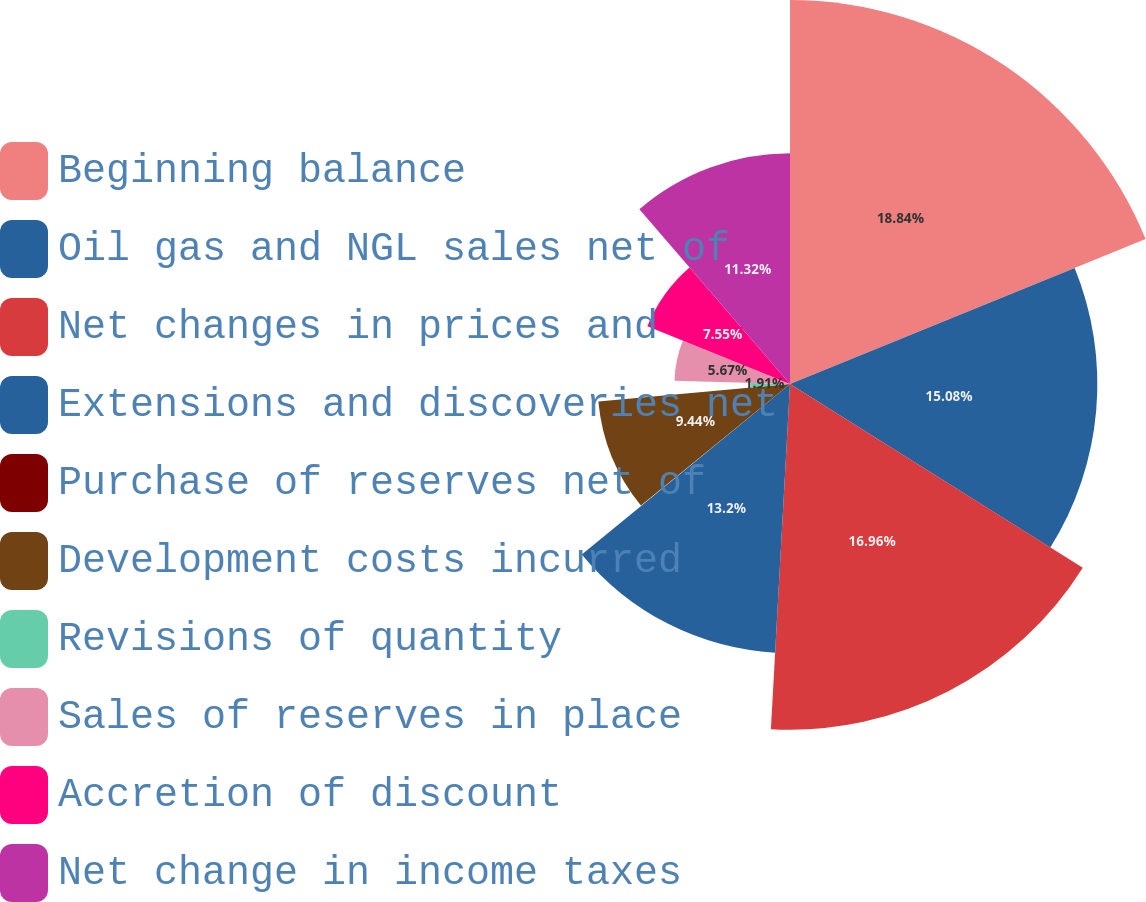Convert chart to OTSL. <chart><loc_0><loc_0><loc_500><loc_500><pie_chart><fcel>Beginning balance<fcel>Oil gas and NGL sales net of<fcel>Net changes in prices and<fcel>Extensions and discoveries net<fcel>Purchase of reserves net of<fcel>Development costs incurred<fcel>Revisions of quantity<fcel>Sales of reserves in place<fcel>Accretion of discount<fcel>Net change in income taxes<nl><fcel>18.84%<fcel>15.08%<fcel>16.96%<fcel>13.2%<fcel>0.03%<fcel>9.44%<fcel>1.91%<fcel>5.67%<fcel>7.55%<fcel>11.32%<nl></chart> 